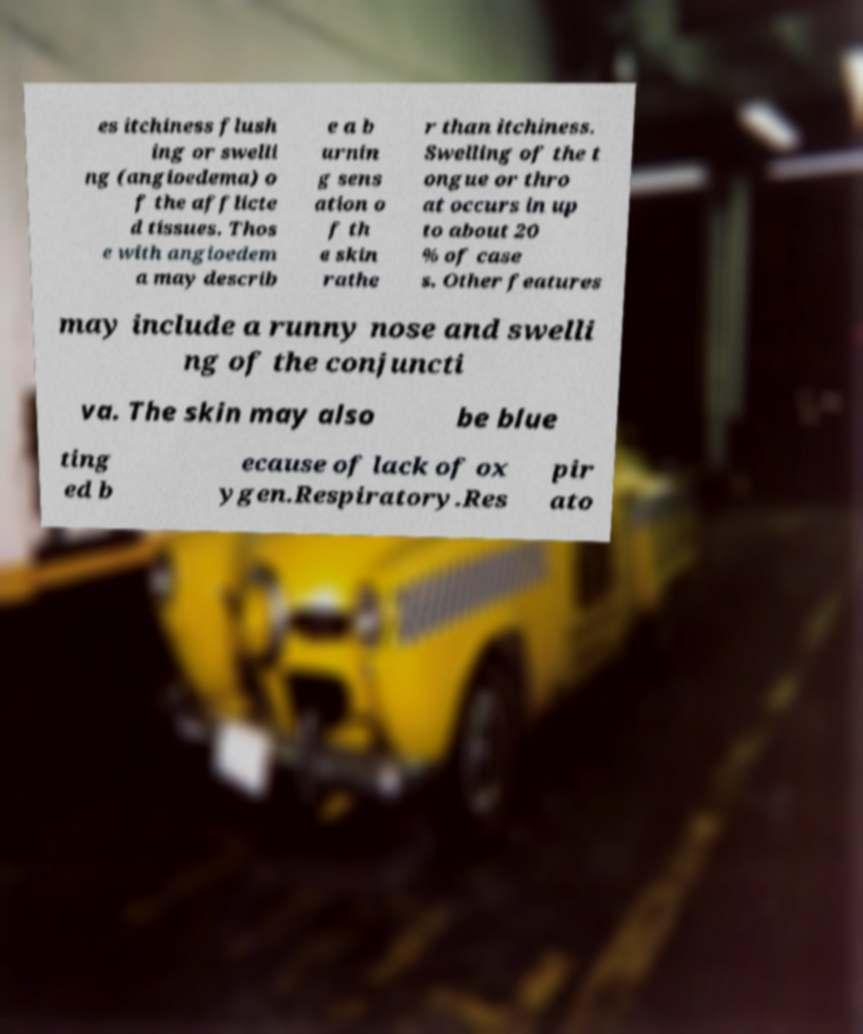Please identify and transcribe the text found in this image. es itchiness flush ing or swelli ng (angioedema) o f the afflicte d tissues. Thos e with angioedem a may describ e a b urnin g sens ation o f th e skin rathe r than itchiness. Swelling of the t ongue or thro at occurs in up to about 20 % of case s. Other features may include a runny nose and swelli ng of the conjuncti va. The skin may also be blue ting ed b ecause of lack of ox ygen.Respiratory.Res pir ato 